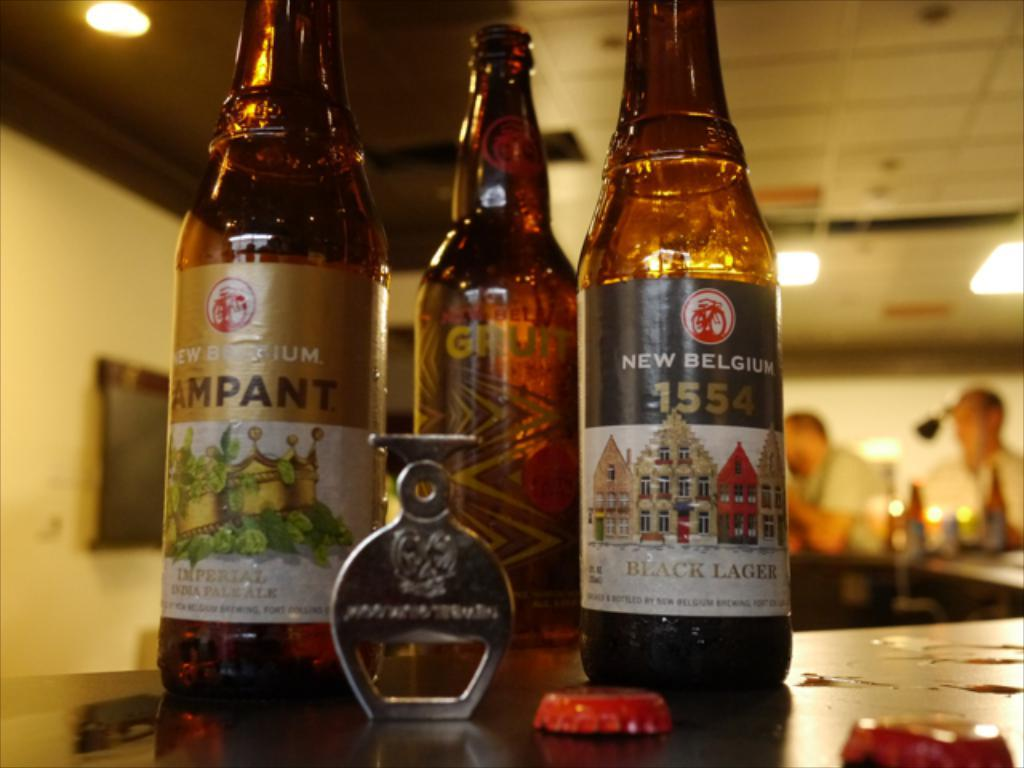<image>
Give a short and clear explanation of the subsequent image. Several bottles of alcohol, including a black lager selection, sit on a counter. 